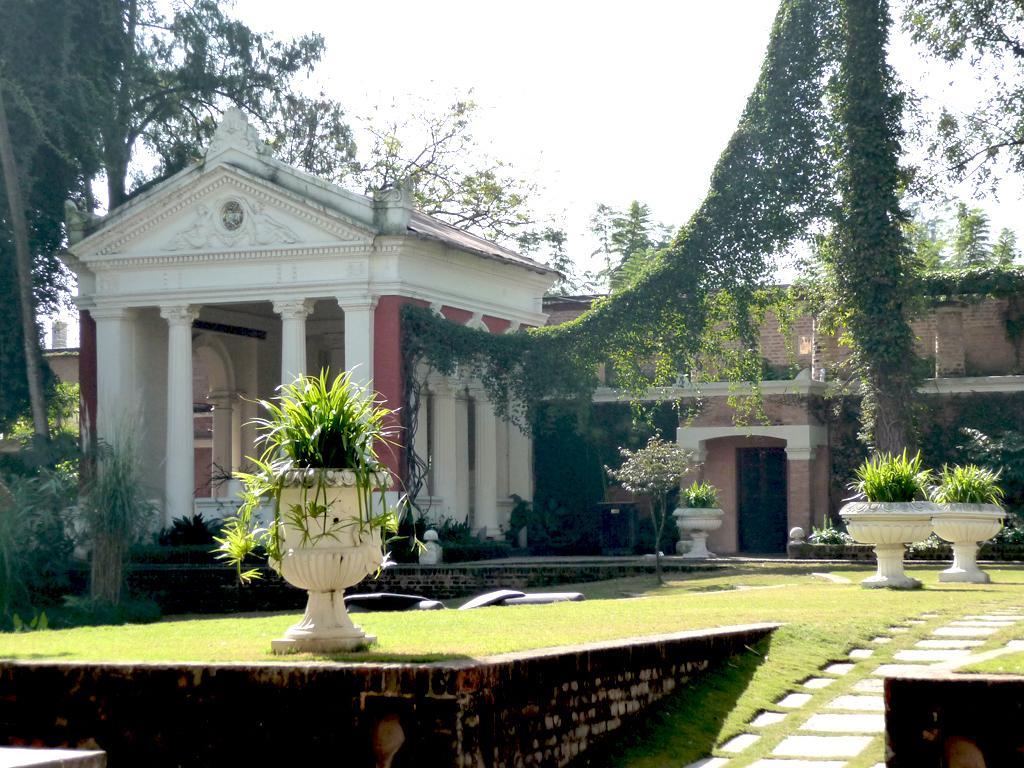Can you describe this image briefly? In this image I can see an open grass ground and on it I can see number of plants and few white colour things. In the background I can see a building, number of trees and the sky. 